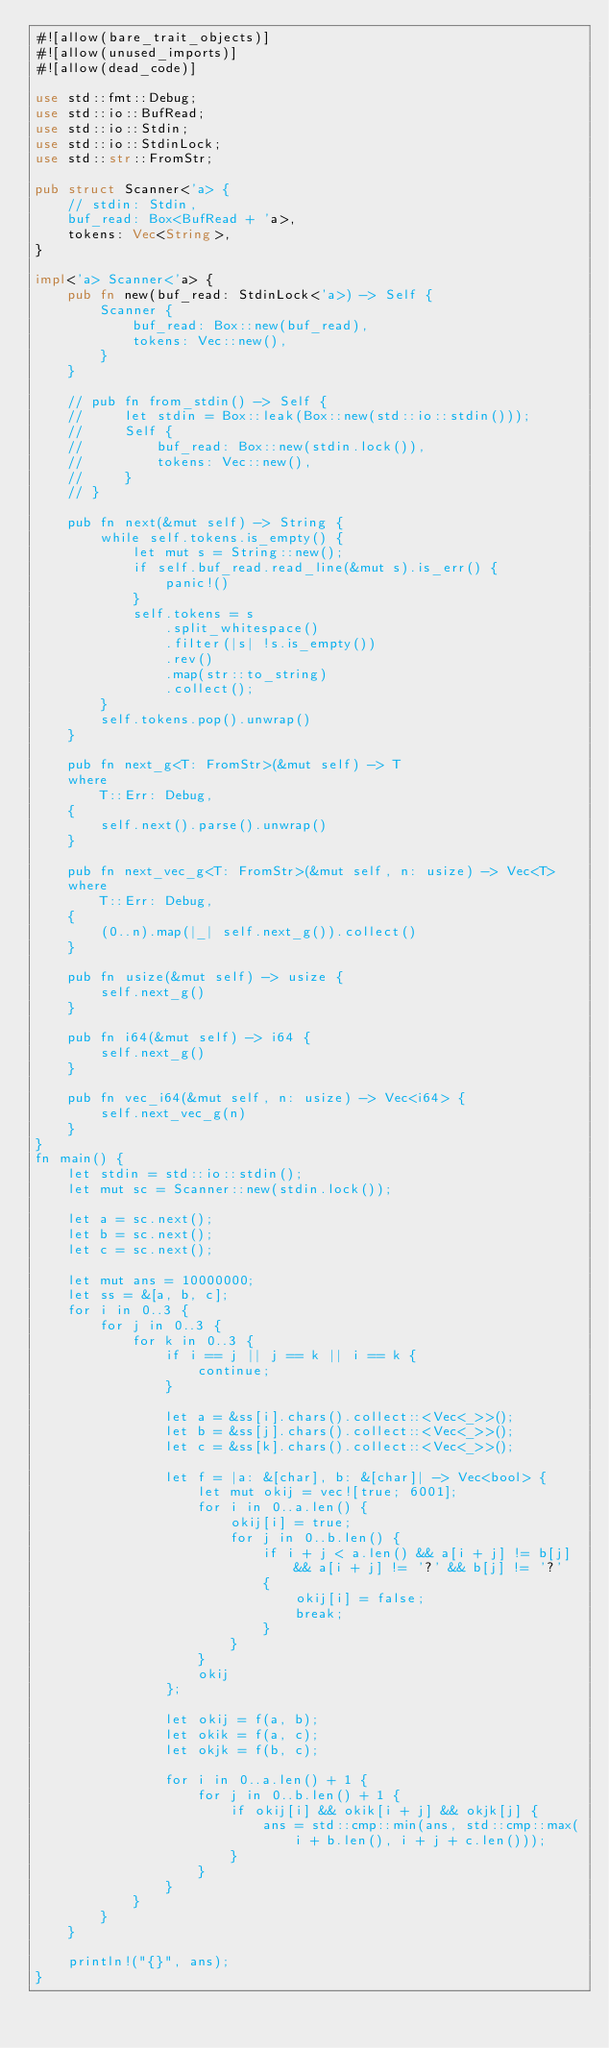<code> <loc_0><loc_0><loc_500><loc_500><_Rust_>#![allow(bare_trait_objects)]
#![allow(unused_imports)]
#![allow(dead_code)]

use std::fmt::Debug;
use std::io::BufRead;
use std::io::Stdin;
use std::io::StdinLock;
use std::str::FromStr;

pub struct Scanner<'a> {
    // stdin: Stdin,
    buf_read: Box<BufRead + 'a>,
    tokens: Vec<String>,
}

impl<'a> Scanner<'a> {
    pub fn new(buf_read: StdinLock<'a>) -> Self {
        Scanner {
            buf_read: Box::new(buf_read),
            tokens: Vec::new(),
        }
    }

    // pub fn from_stdin() -> Self {
    //     let stdin = Box::leak(Box::new(std::io::stdin()));
    //     Self {
    //         buf_read: Box::new(stdin.lock()),
    //         tokens: Vec::new(),
    //     }
    // }

    pub fn next(&mut self) -> String {
        while self.tokens.is_empty() {
            let mut s = String::new();
            if self.buf_read.read_line(&mut s).is_err() {
                panic!()
            }
            self.tokens = s
                .split_whitespace()
                .filter(|s| !s.is_empty())
                .rev()
                .map(str::to_string)
                .collect();
        }
        self.tokens.pop().unwrap()
    }

    pub fn next_g<T: FromStr>(&mut self) -> T
    where
        T::Err: Debug,
    {
        self.next().parse().unwrap()
    }

    pub fn next_vec_g<T: FromStr>(&mut self, n: usize) -> Vec<T>
    where
        T::Err: Debug,
    {
        (0..n).map(|_| self.next_g()).collect()
    }

    pub fn usize(&mut self) -> usize {
        self.next_g()
    }

    pub fn i64(&mut self) -> i64 {
        self.next_g()
    }

    pub fn vec_i64(&mut self, n: usize) -> Vec<i64> {
        self.next_vec_g(n)
    }
}
fn main() {
    let stdin = std::io::stdin();
    let mut sc = Scanner::new(stdin.lock());

    let a = sc.next();
    let b = sc.next();
    let c = sc.next();

    let mut ans = 10000000;
    let ss = &[a, b, c];
    for i in 0..3 {
        for j in 0..3 {
            for k in 0..3 {
                if i == j || j == k || i == k {
                    continue;
                }

                let a = &ss[i].chars().collect::<Vec<_>>();
                let b = &ss[j].chars().collect::<Vec<_>>();
                let c = &ss[k].chars().collect::<Vec<_>>();

                let f = |a: &[char], b: &[char]| -> Vec<bool> {
                    let mut okij = vec![true; 6001];
                    for i in 0..a.len() {
                        okij[i] = true;
                        for j in 0..b.len() {
                            if i + j < a.len() && a[i + j] != b[j] && a[i + j] != '?' && b[j] != '?'
                            {
                                okij[i] = false;
                                break;
                            }
                        }
                    }
                    okij
                };

                let okij = f(a, b);
                let okik = f(a, c);
                let okjk = f(b, c);

                for i in 0..a.len() + 1 {
                    for j in 0..b.len() + 1 {
                        if okij[i] && okik[i + j] && okjk[j] {
                            ans = std::cmp::min(ans, std::cmp::max(i + b.len(), i + j + c.len()));
                        }
                    }
                }
            }
        }
    }

    println!("{}", ans);
}
</code> 